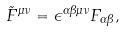<formula> <loc_0><loc_0><loc_500><loc_500>\tilde { F } ^ { \mu \nu } = \epsilon ^ { \alpha \beta \mu \nu } F _ { \alpha \beta } ,</formula> 